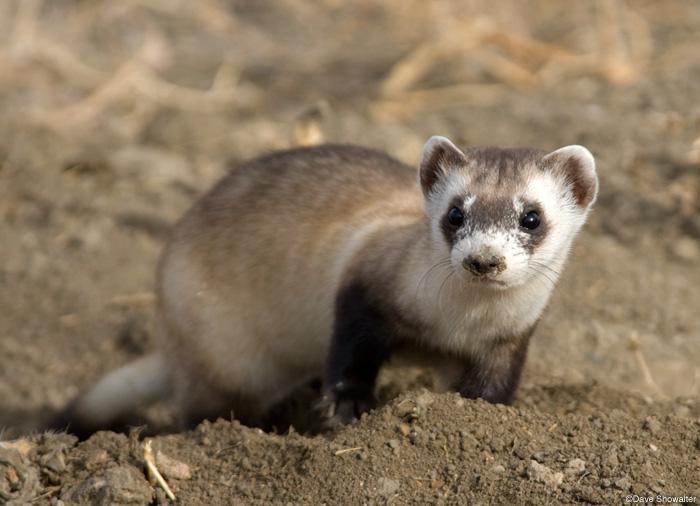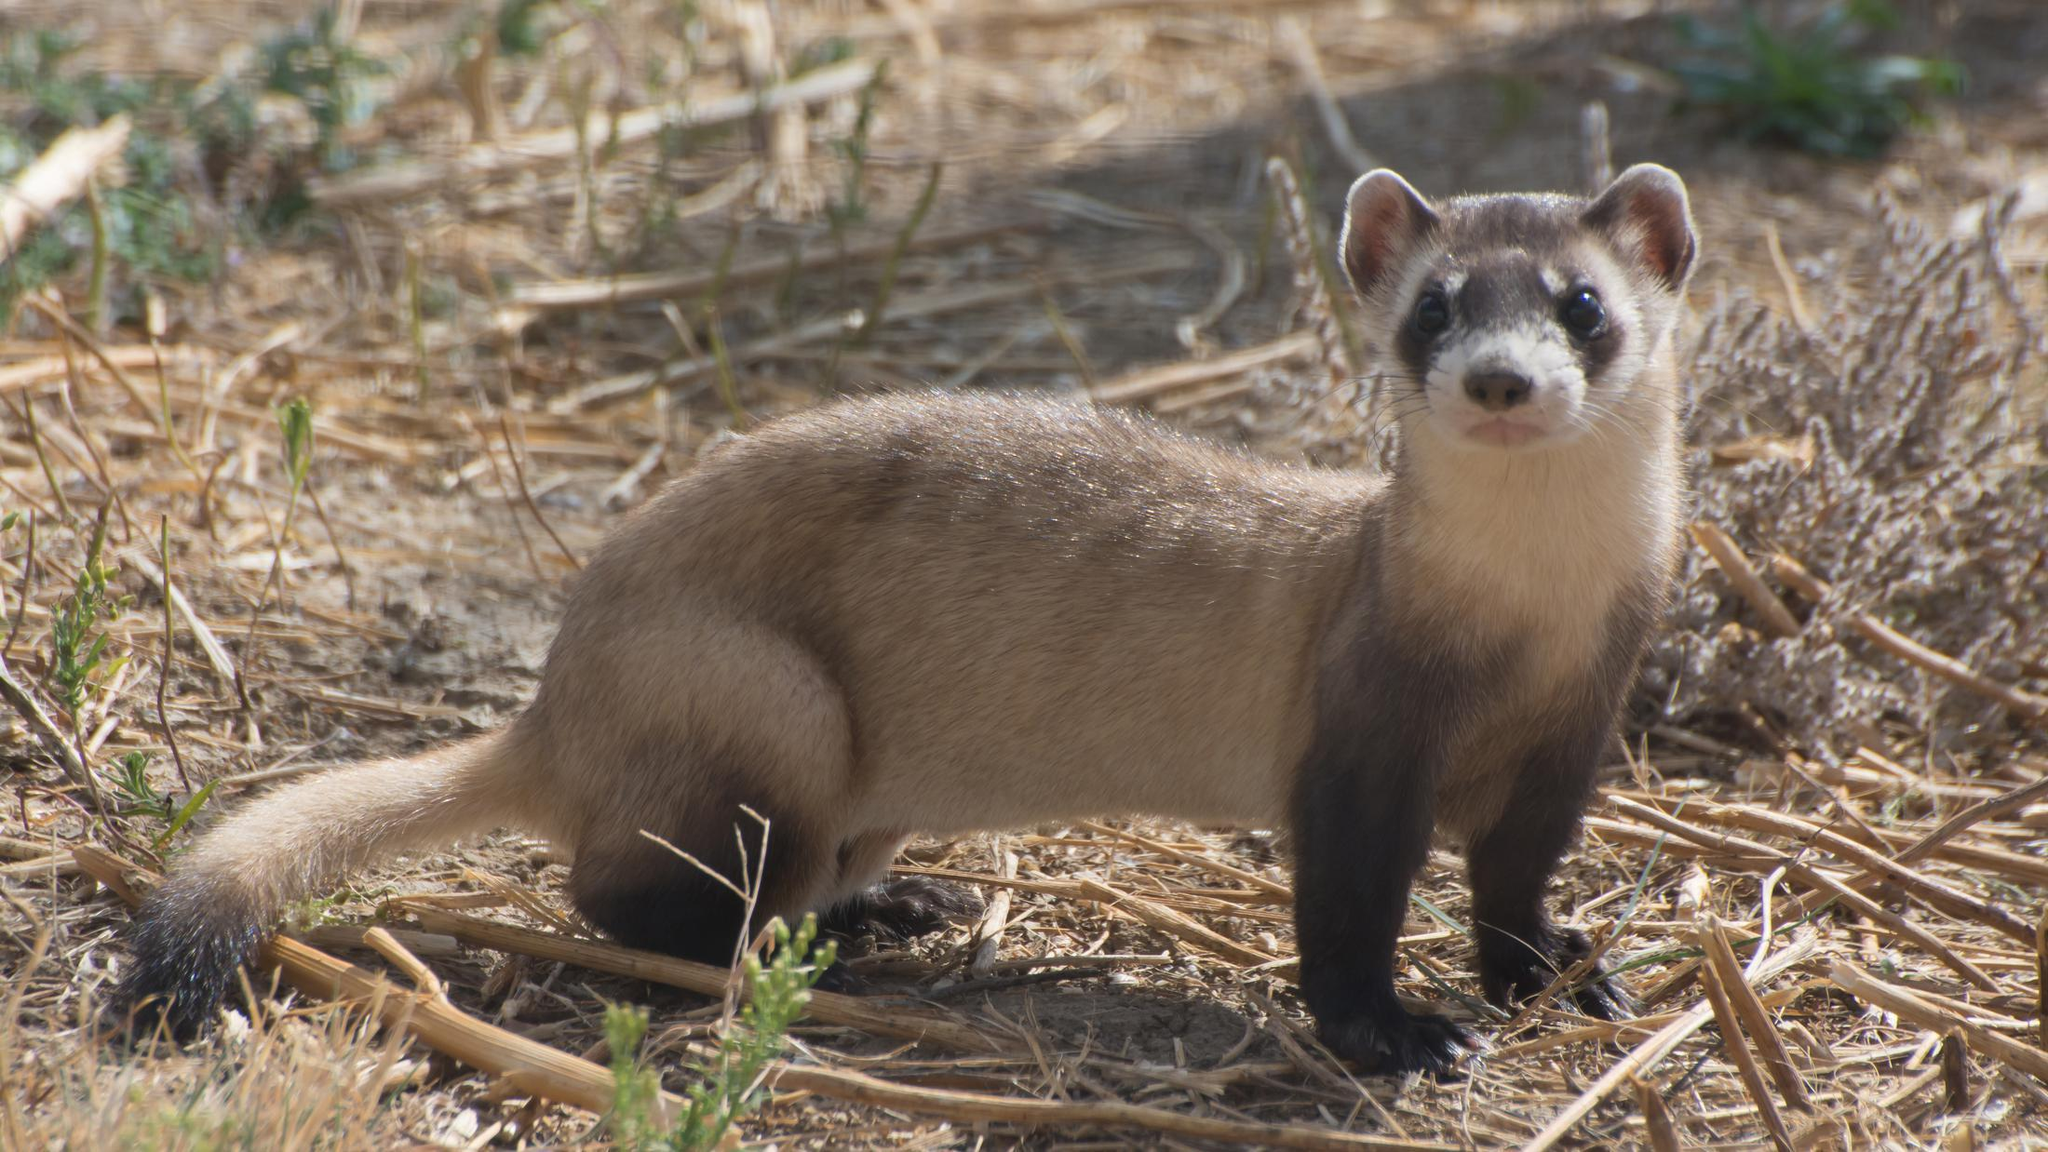The first image is the image on the left, the second image is the image on the right. For the images shown, is this caption "There are two animals" true? Answer yes or no. Yes. The first image is the image on the left, the second image is the image on the right. Given the left and right images, does the statement "Each image contains exactly one animal." hold true? Answer yes or no. Yes. 